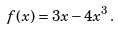Convert formula to latex. <formula><loc_0><loc_0><loc_500><loc_500>f ( x ) = 3 x - 4 x ^ { 3 } \, .</formula> 